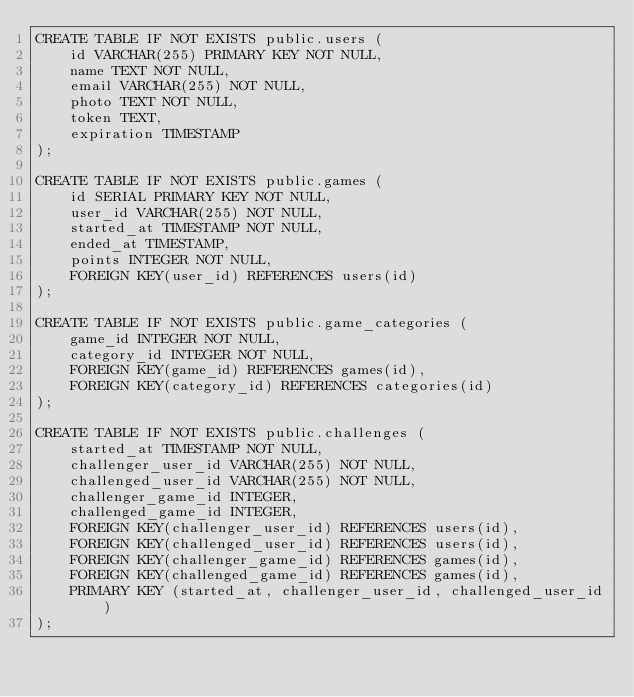Convert code to text. <code><loc_0><loc_0><loc_500><loc_500><_SQL_>CREATE TABLE IF NOT EXISTS public.users (
    id VARCHAR(255) PRIMARY KEY NOT NULL,
    name TEXT NOT NULL,
    email VARCHAR(255) NOT NULL,
    photo TEXT NOT NULL,
    token TEXT,
    expiration TIMESTAMP
);

CREATE TABLE IF NOT EXISTS public.games (
    id SERIAL PRIMARY KEY NOT NULL,
    user_id VARCHAR(255) NOT NULL,
    started_at TIMESTAMP NOT NULL,
    ended_at TIMESTAMP,
    points INTEGER NOT NULL,
    FOREIGN KEY(user_id) REFERENCES users(id)
);

CREATE TABLE IF NOT EXISTS public.game_categories (
    game_id INTEGER NOT NULL,
    category_id INTEGER NOT NULL,
    FOREIGN KEY(game_id) REFERENCES games(id),
    FOREIGN KEY(category_id) REFERENCES categories(id)
);

CREATE TABLE IF NOT EXISTS public.challenges (
    started_at TIMESTAMP NOT NULL,
    challenger_user_id VARCHAR(255) NOT NULL,
    challenged_user_id VARCHAR(255) NOT NULL,
    challenger_game_id INTEGER,
    challenged_game_id INTEGER,
    FOREIGN KEY(challenger_user_id) REFERENCES users(id),
    FOREIGN KEY(challenged_user_id) REFERENCES users(id),
    FOREIGN KEY(challenger_game_id) REFERENCES games(id),
    FOREIGN KEY(challenged_game_id) REFERENCES games(id),
    PRIMARY KEY (started_at, challenger_user_id, challenged_user_id)
);
</code> 